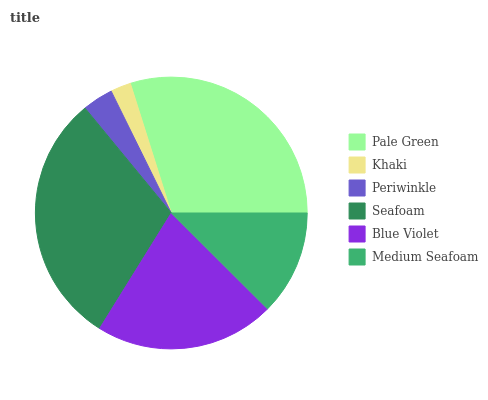Is Khaki the minimum?
Answer yes or no. Yes. Is Seafoam the maximum?
Answer yes or no. Yes. Is Periwinkle the minimum?
Answer yes or no. No. Is Periwinkle the maximum?
Answer yes or no. No. Is Periwinkle greater than Khaki?
Answer yes or no. Yes. Is Khaki less than Periwinkle?
Answer yes or no. Yes. Is Khaki greater than Periwinkle?
Answer yes or no. No. Is Periwinkle less than Khaki?
Answer yes or no. No. Is Blue Violet the high median?
Answer yes or no. Yes. Is Medium Seafoam the low median?
Answer yes or no. Yes. Is Periwinkle the high median?
Answer yes or no. No. Is Khaki the low median?
Answer yes or no. No. 